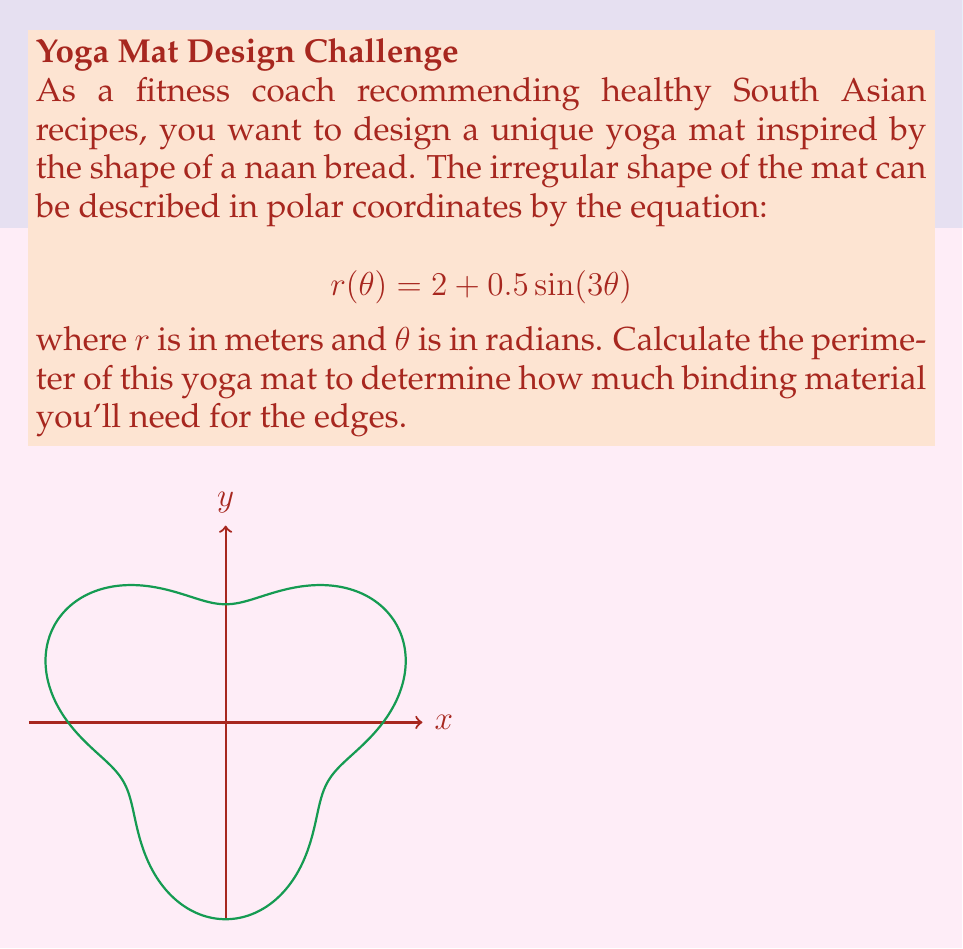Help me with this question. To find the perimeter of the yoga mat, we need to use the arc length formula for polar curves:

$$L = \int_0^{2\pi} \sqrt{r^2 + \left(\frac{dr}{d\theta}\right)^2} d\theta$$

Step 1: Find $\frac{dr}{d\theta}$
$$\frac{dr}{d\theta} = 1.5\cos(3\theta)$$

Step 2: Calculate $r^2 + \left(\frac{dr}{d\theta}\right)^2$
$$r^2 + \left(\frac{dr}{d\theta}\right)^2 = (2 + 0.5\sin(3\theta))^2 + (1.5\cos(3\theta))^2$$

Step 3: Simplify the expression under the square root
$$\sqrt{r^2 + \left(\frac{dr}{d\theta}\right)^2} = \sqrt{4 + 2\sin(3\theta) + 0.25\sin^2(3\theta) + 2.25\cos^2(3\theta)}$$

Step 4: Set up the integral
$$L = \int_0^{2\pi} \sqrt{4 + 2\sin(3\theta) + 0.25\sin^2(3\theta) + 2.25\cos^2(3\theta)} d\theta$$

Step 5: This integral cannot be solved analytically, so we need to use numerical integration methods. Using a computer algebra system or numerical integration tool, we can approximate the value of this integral.

The result of the numerical integration is approximately 13.0598 meters.
Answer: $13.06$ m (rounded to two decimal places) 